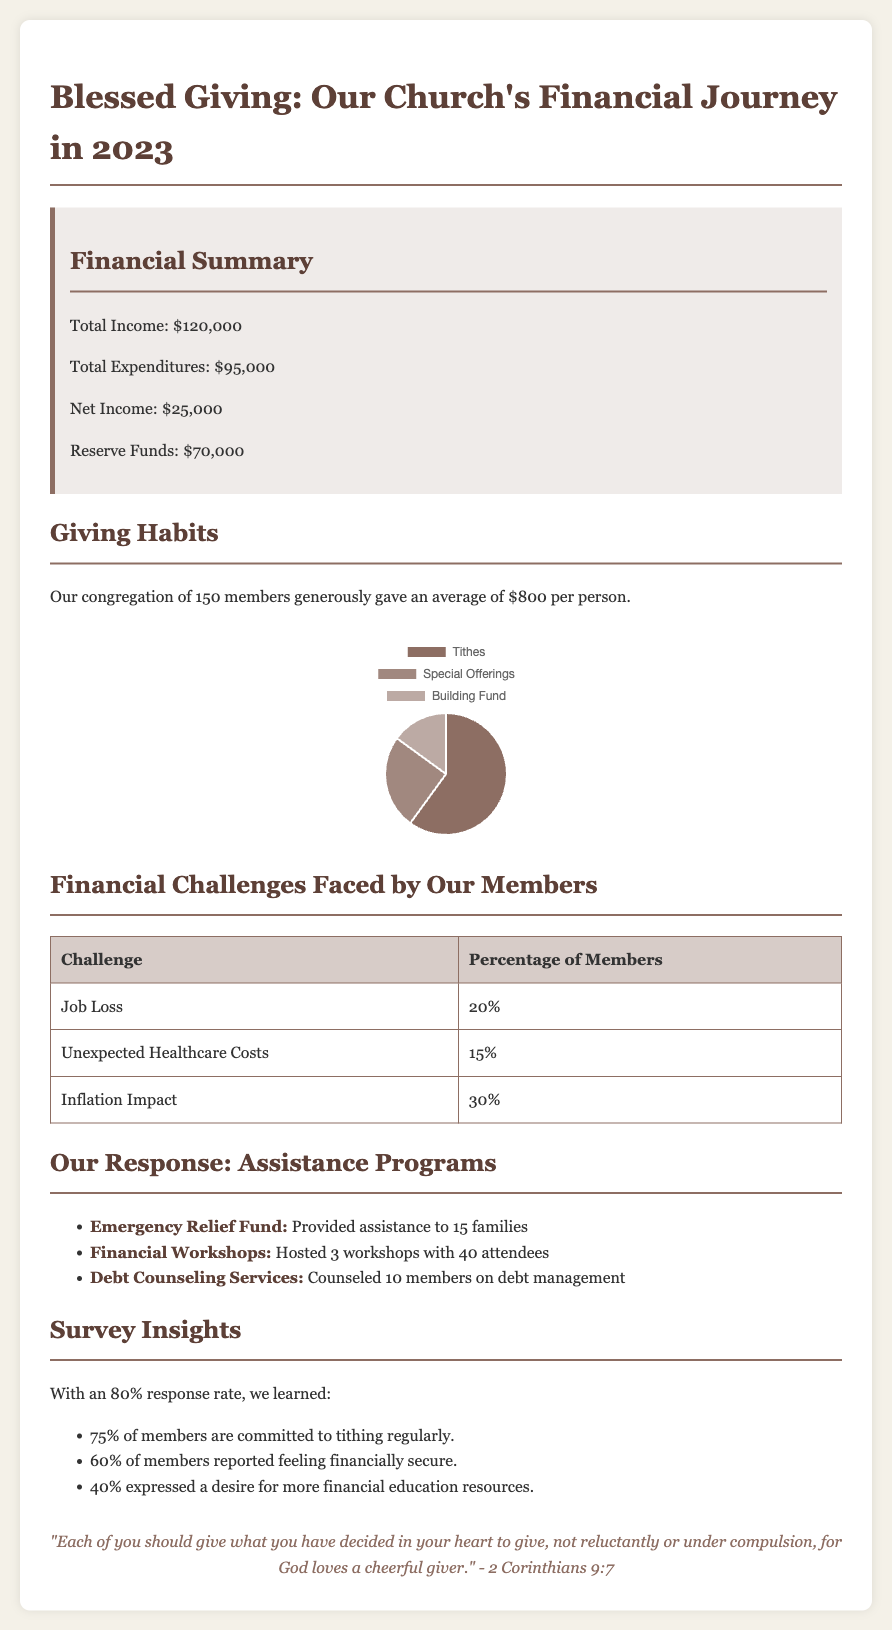What is the total income? The total income is explicitly stated in the financial summary section.
Answer: $120,000 What percentage of members faced inflation impact? This percentage is found in the table outlining financial challenges faced by members.
Answer: 30% How much assistance was provided to families through the Emergency Relief Fund? The amount of assistance is mentioned in the response to community needs section.
Answer: 15 families What was the average giving per member? This figure is provided in the giving habits section of the report.
Answer: $800 What percentage of members are committed to tithing regularly? This statistic is included in the survey insights section.
Answer: 75% How many financial workshops were hosted this year? The number of workshops is listed under the assistance programs section.
Answer: 3 What is the total expenditure? The total expenditure is specified in the financial summary.
Answer: $95,000 What is the net income for the year? The net income is calculated from total income minus total expenditures in the report.
Answer: $25,000 What percentage of members reported feeling financially secure? This information is presented in the survey insights section of the document.
Answer: 60% 